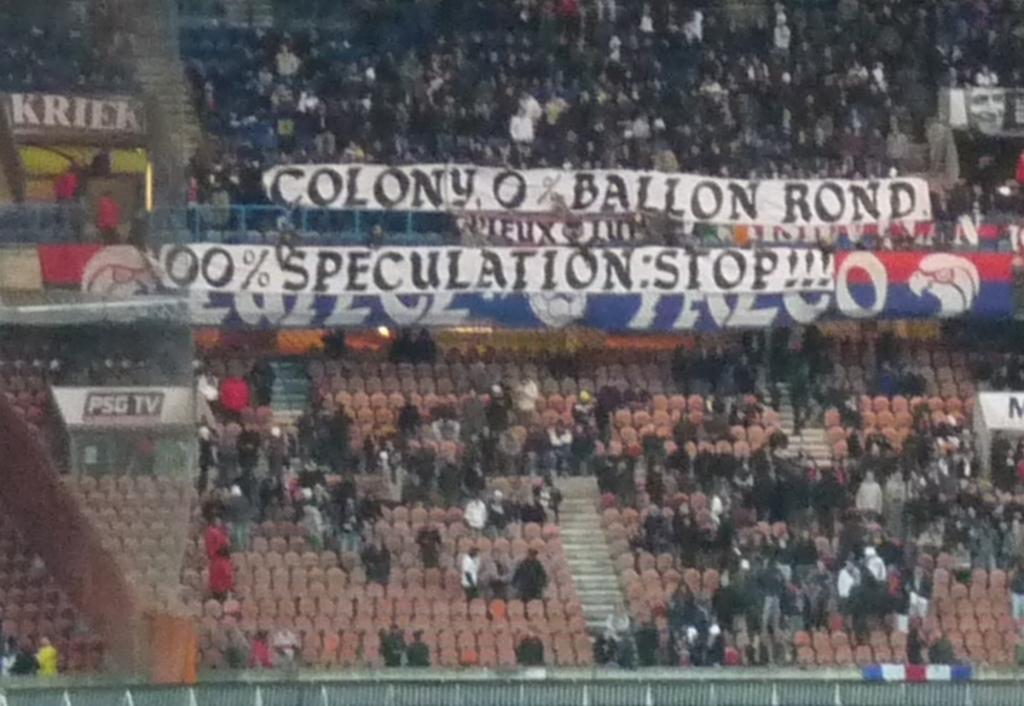<image>
Offer a succinct explanation of the picture presented. A sign for PSG TV can be seen in an arena. 